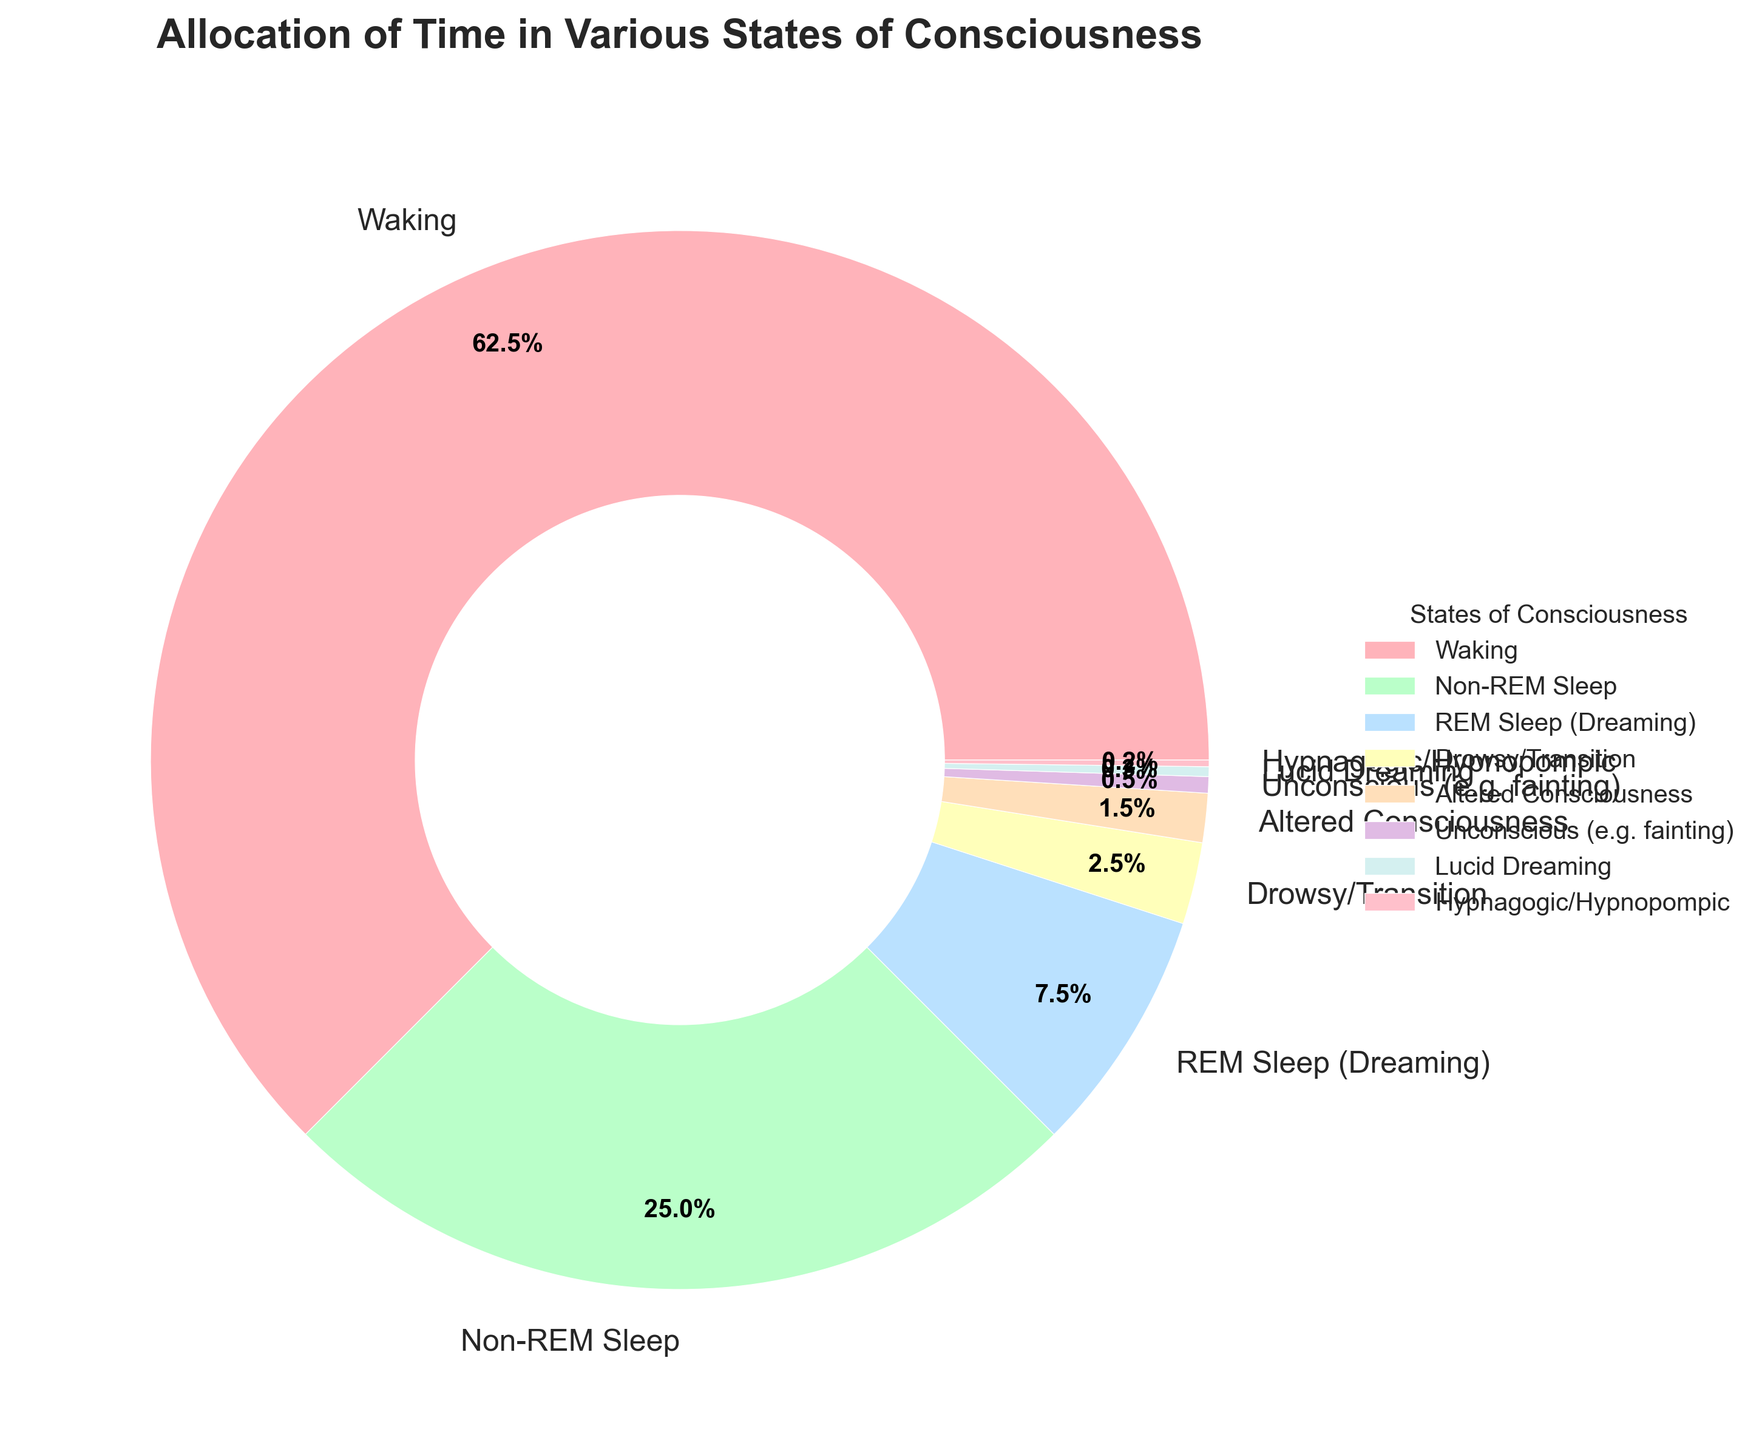What is the most time-consuming state of consciousness? The largest wedge in the pie chart represents Waking, with 62.5%. Therefore, Waking is the most time-consuming state of consciousness.
Answer: Waking What is the sum of the percentages for Non-REM Sleep and REM Sleep (Dreaming)? From the chart, Non-REM Sleep is 25.0% and REM Sleep (Dreaming) is 7.5%. Adding these together: 25.0 + 7.5 = 32.5%.
Answer: 32.5% Which state of consciousness occupies the least percentage of time? The smallest wedge in the pie chart represents Hypnagogic/Hypnopompic, with 0.2%. Therefore, Hypnagogic/Hypnopompic occupies the least percentage of time.
Answer: Hypnagogic/Hypnopompic Is the time spent in Drowsy/Transition greater than in Lucid Dreaming? The pie chart shows that Drowsy/Transition is 2.5%, and Lucid Dreaming is 0.3%. Since 2.5% > 0.3%, the time spent in Drowsy/Transition is indeed greater.
Answer: Yes What is the combined percentage of time spent in states of altered consciousness (Altered Consciousness, Lucid Dreaming, and Hypnagogic/Hypnopompic)? From the chart: Altered Consciousness is 1.5%, Lucid Dreaming is 0.3%, and Hypnagogic/Hypnopompic is 0.2%. Adding these together: 1.5 + 0.3 + 0.2 = 2.0%.
Answer: 2.0% Does Non-REM Sleep occupy more time than combined REM Sleep (Dreaming) and Drowsy/Transition? Non-REM Sleep is 25.0%. Combined REM Sleep (Dreaming) and Drowsy/Transition is 7.5 + 2.5 = 10.0%. 25.0% > 10.0%, so Non-REM Sleep does occupy more time.
Answer: Yes Which state is represented by the green section of the pie chart? The green section of the pie chart represents Non-REM Sleep, which occupies 25.0% of the time.
Answer: Non-REM Sleep What is the difference in time allocation between Waking and Non-REM Sleep? Waking is 62.5%, and Non-REM Sleep is 25.0%. The difference is 62.5 - 25.0 = 37.5%.
Answer: 37.5% Which two states combined occupy exactly 3.0% of the time? The percentages for Unconscious (e.g., fainting) and Lucid Dreaming are 0.5% and 0.3%, respectively. The sum is 0.5 + 0.3 = 0.8%. However, Drowsy/Transition is 2.5% and Hypnagogic/Hypnopompic is 0.2%. The sum is 2.5 + 0.2 = 2.7%. The combination of states that exactly equals 3.0% does not exist on this chart.
Answer: None 